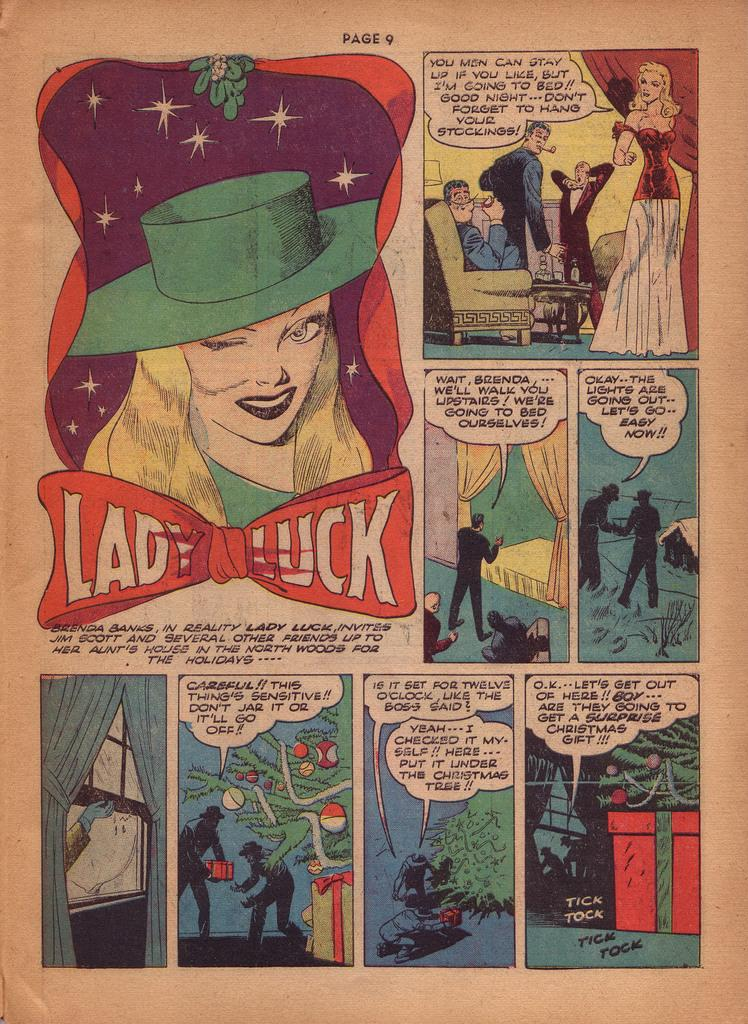<image>
Write a terse but informative summary of the picture. A paper comic strip page titled Lady Luck. 